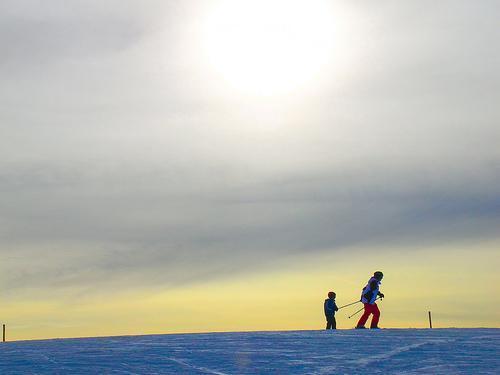How many people are there?
Give a very brief answer. 2. 